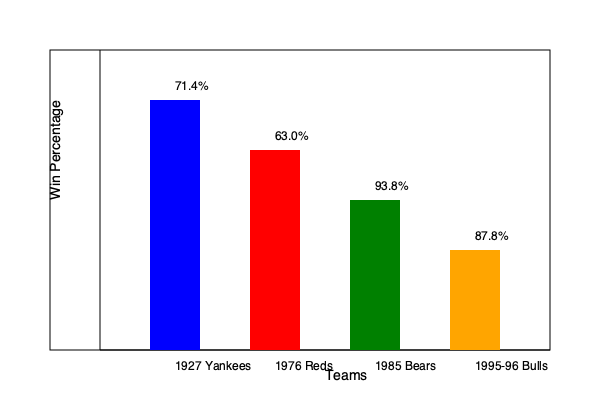Examine the comparative bar graph showcasing the win percentages of four legendary sports teams from different eras. If the 1927 New York Yankees had maintained their win percentage for an additional 10 games beyond their actual 154-game season, how many more wins would they have theoretically accumulated compared to the 1976 Cincinnati Reds over a hypothetical 164-game season? To solve this problem, we'll follow these steps:

1. Calculate the number of wins for the 1927 Yankees in a 164-game season:
   * Win percentage = 71.4%
   * Wins = $0.714 \times 164 = 117.096$ games

2. Calculate the number of wins for the 1976 Reds in a 164-game season:
   * Win percentage = 63.0%
   * Wins = $0.630 \times 164 = 103.32$ games

3. Find the difference in wins:
   * Difference = Yankees wins - Reds wins
   * Difference = $117.096 - 103.32 = 13.776$ games

4. Round to the nearest whole number:
   * 13.776 rounds to 14 games

Therefore, if both teams played a hypothetical 164-game season, the 1927 Yankees would have won approximately 14 more games than the 1976 Reds.

This analysis allows us to compare teams from different eras and leagues on a level playing field, demonstrating how dominant the 1927 Yankees were compared to another legendary team like the 1976 Reds.
Answer: 14 more wins 